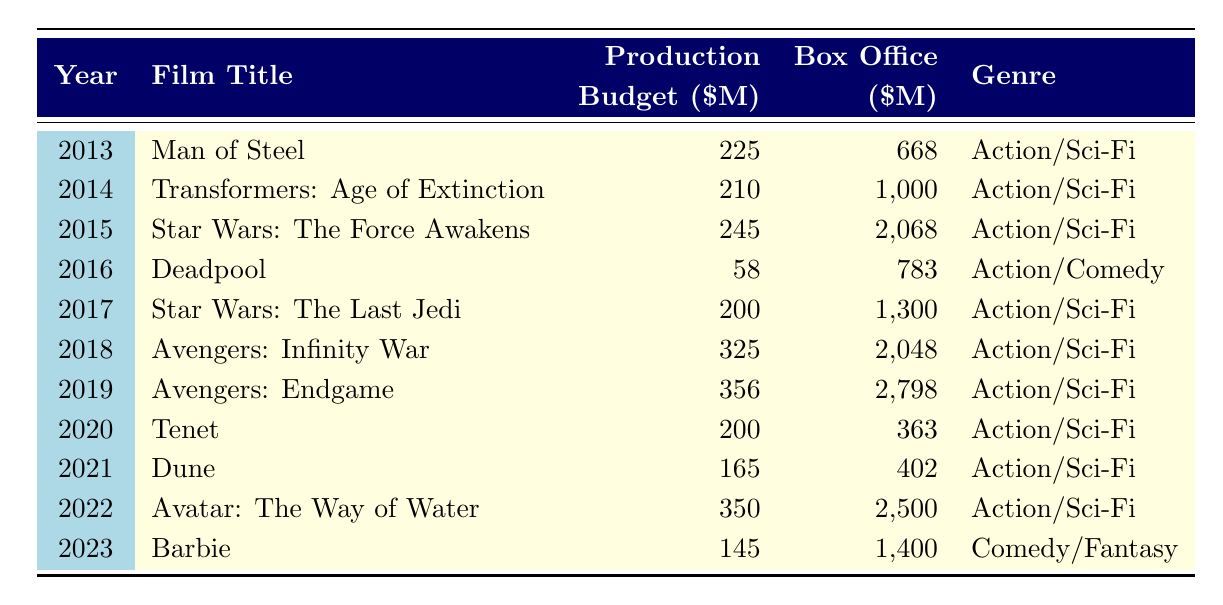What was the film with the highest production budget in 2022? According to the table, the film "Avatar: The Way of Water" was released in 2022 with a production budget of 350 million dollars, which is the highest budget listed for that year.
Answer: Avatar: The Way of Water Which film had a lower box office than its production budget in 2020? In 2020, the film "Tenet" had a production budget of 200 million dollars, but its box office was only 363 million dollars, which is less than its budget.
Answer: Tenet What is the total production budget for the films released from 2013 to 2015? To find the total production budget from 2013 to 2015, we add the budgets of "Man of Steel" (225), "Transformers: Age of Extinction" (210), and "Star Wars: The Force Awakens" (245). Summing these up gives us 225 + 210 + 245 = 680 million dollars.
Answer: 680 Is the genre of "Deadpool" classified as Action/Sci-Fi? The table specifies that "Deadpool" is categorized as Action/Comedy, not Action/Sci-Fi. Therefore, the statement is false.
Answer: No What was the average production budget for the films released in 2019 and 2022? The production budgets for 2019 ("Avengers: Endgame") and 2022 ("Avatar: The Way of Water") are 356 million and 350 million respectively. To find the average, we sum these: 356 + 350 = 706 million, and then divide by 2: 706 / 2 = 353 million dollars.
Answer: 353 